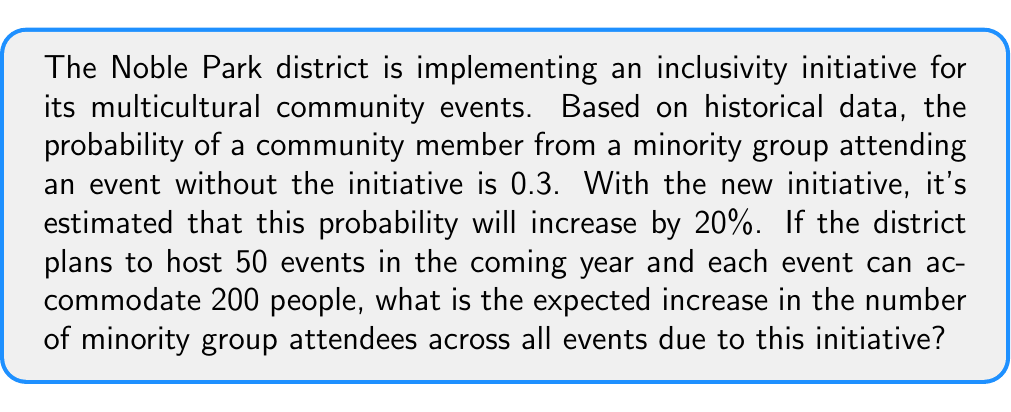Can you answer this question? Let's approach this problem step-by-step using probability theory and expected value calculations:

1) First, let's define our probabilities:
   - Without initiative: $p_1 = 0.3$
   - With initiative: $p_2 = 0.3 \times 1.2 = 0.36$ (20% increase)

2) Now, let's calculate the expected number of minority attendees per event:
   - Without initiative: $E_1 = 200 \times 0.3 = 60$
   - With initiative: $E_2 = 200 \times 0.36 = 72$

3) The increase in expected attendees per event is:
   $\Delta E = E_2 - E_1 = 72 - 60 = 12$

4) For 50 events, the total expected increase is:
   $\text{Total } \Delta E = 50 \times 12 = 600$

Therefore, the expected increase in the number of minority group attendees across all 50 events due to this initiative is 600.

To express this mathematically:

$$\begin{aligned}
\text{Total } \Delta E &= n \times C \times (p_2 - p_1) \\
&= 50 \times 200 \times (0.36 - 0.3) \\
&= 50 \times 200 \times 0.06 \\
&= 600
\end{aligned}$$

Where:
$n$ is the number of events
$C$ is the capacity per event
$p_1$ is the probability of attendance without the initiative
$p_2$ is the probability of attendance with the initiative
Answer: 600 additional minority group attendees 